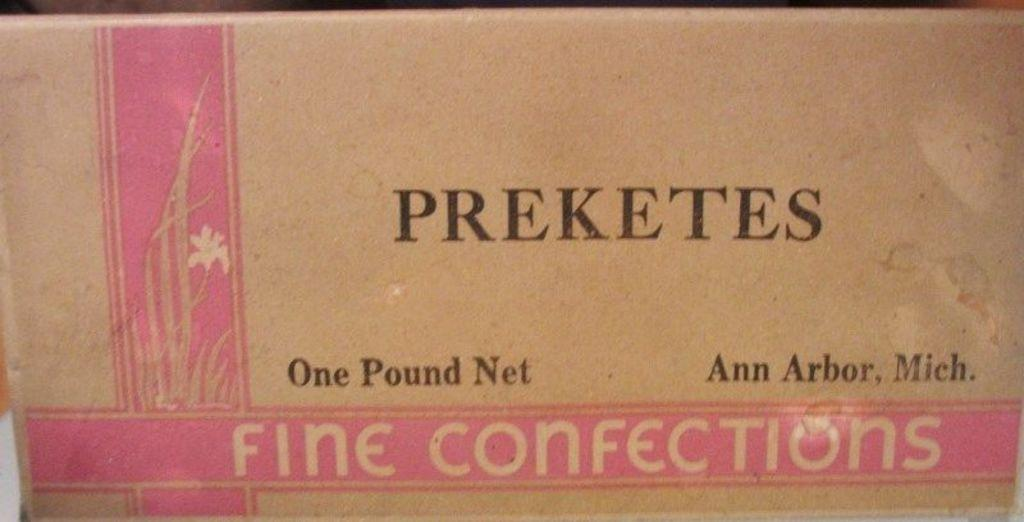<image>
Present a compact description of the photo's key features. A cardboard box containing one pound of preketes fine confections. 